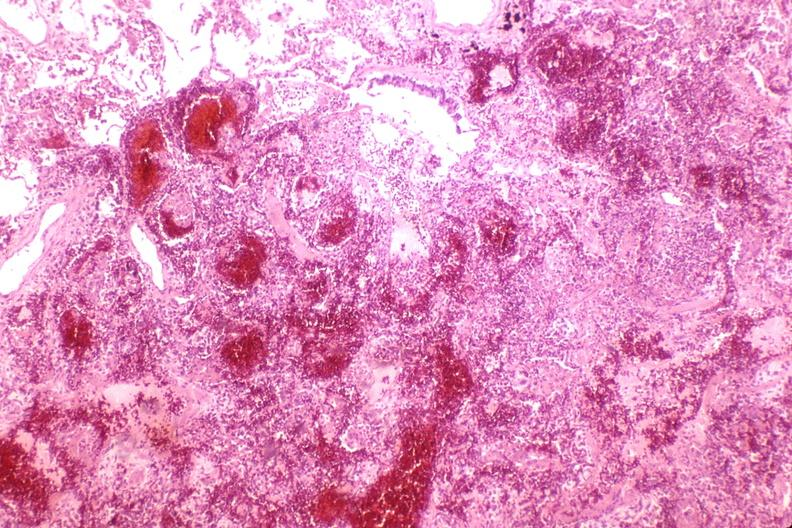s respiratory present?
Answer the question using a single word or phrase. Yes 